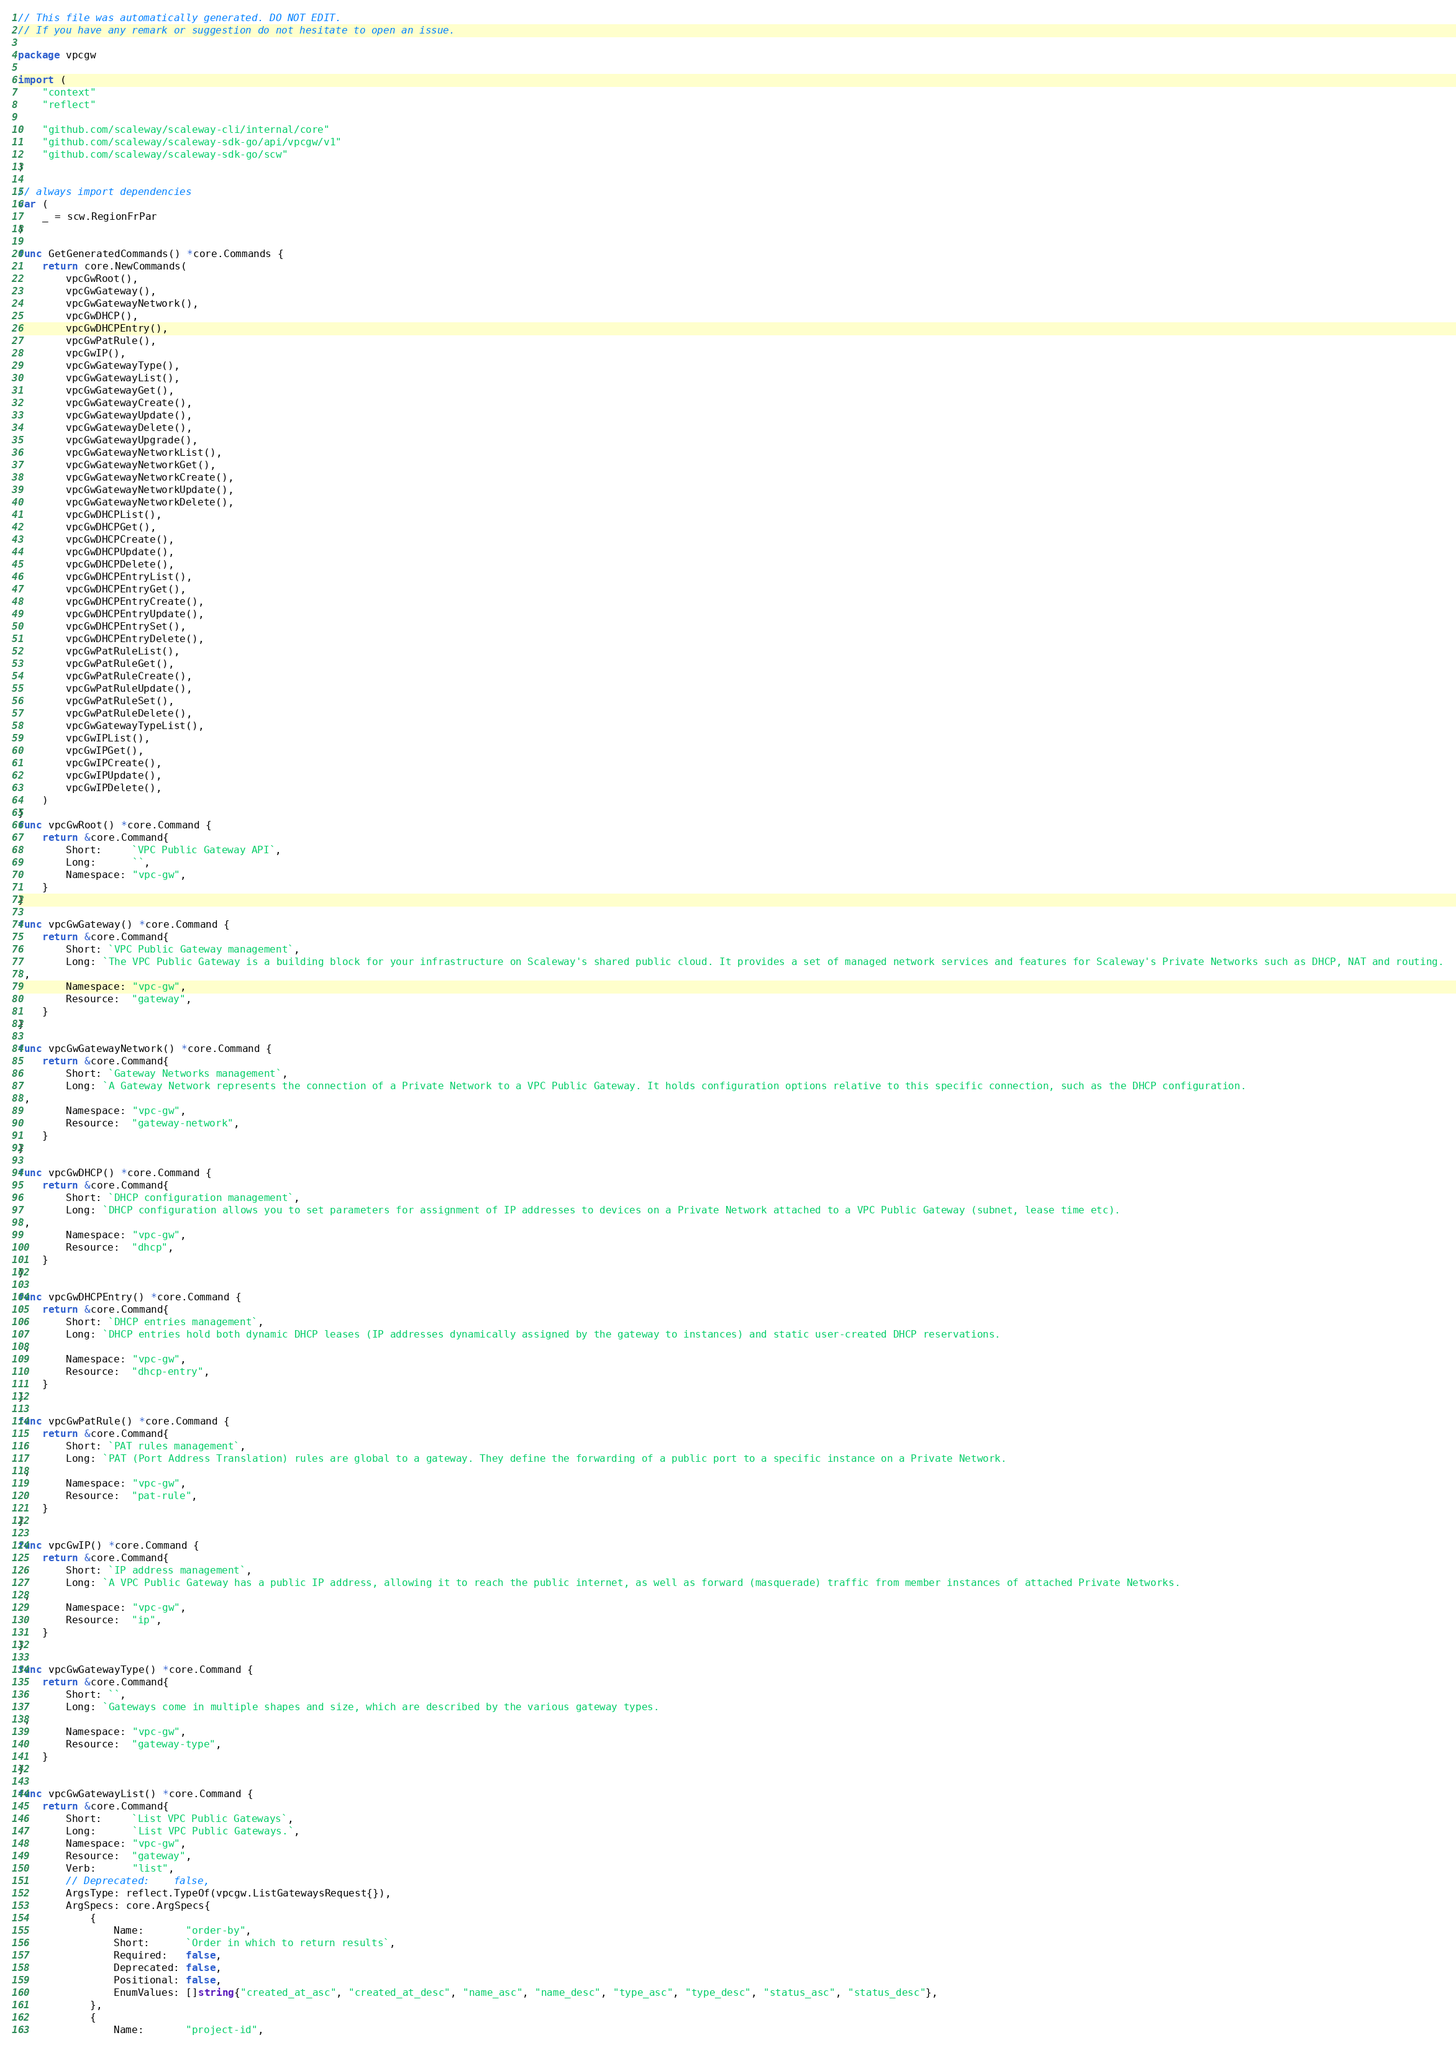Convert code to text. <code><loc_0><loc_0><loc_500><loc_500><_Go_>// This file was automatically generated. DO NOT EDIT.
// If you have any remark or suggestion do not hesitate to open an issue.

package vpcgw

import (
	"context"
	"reflect"

	"github.com/scaleway/scaleway-cli/internal/core"
	"github.com/scaleway/scaleway-sdk-go/api/vpcgw/v1"
	"github.com/scaleway/scaleway-sdk-go/scw"
)

// always import dependencies
var (
	_ = scw.RegionFrPar
)

func GetGeneratedCommands() *core.Commands {
	return core.NewCommands(
		vpcGwRoot(),
		vpcGwGateway(),
		vpcGwGatewayNetwork(),
		vpcGwDHCP(),
		vpcGwDHCPEntry(),
		vpcGwPatRule(),
		vpcGwIP(),
		vpcGwGatewayType(),
		vpcGwGatewayList(),
		vpcGwGatewayGet(),
		vpcGwGatewayCreate(),
		vpcGwGatewayUpdate(),
		vpcGwGatewayDelete(),
		vpcGwGatewayUpgrade(),
		vpcGwGatewayNetworkList(),
		vpcGwGatewayNetworkGet(),
		vpcGwGatewayNetworkCreate(),
		vpcGwGatewayNetworkUpdate(),
		vpcGwGatewayNetworkDelete(),
		vpcGwDHCPList(),
		vpcGwDHCPGet(),
		vpcGwDHCPCreate(),
		vpcGwDHCPUpdate(),
		vpcGwDHCPDelete(),
		vpcGwDHCPEntryList(),
		vpcGwDHCPEntryGet(),
		vpcGwDHCPEntryCreate(),
		vpcGwDHCPEntryUpdate(),
		vpcGwDHCPEntrySet(),
		vpcGwDHCPEntryDelete(),
		vpcGwPatRuleList(),
		vpcGwPatRuleGet(),
		vpcGwPatRuleCreate(),
		vpcGwPatRuleUpdate(),
		vpcGwPatRuleSet(),
		vpcGwPatRuleDelete(),
		vpcGwGatewayTypeList(),
		vpcGwIPList(),
		vpcGwIPGet(),
		vpcGwIPCreate(),
		vpcGwIPUpdate(),
		vpcGwIPDelete(),
	)
}
func vpcGwRoot() *core.Command {
	return &core.Command{
		Short:     `VPC Public Gateway API`,
		Long:      ``,
		Namespace: "vpc-gw",
	}
}

func vpcGwGateway() *core.Command {
	return &core.Command{
		Short: `VPC Public Gateway management`,
		Long: `The VPC Public Gateway is a building block for your infrastructure on Scaleway's shared public cloud. It provides a set of managed network services and features for Scaleway's Private Networks such as DHCP, NAT and routing.
`,
		Namespace: "vpc-gw",
		Resource:  "gateway",
	}
}

func vpcGwGatewayNetwork() *core.Command {
	return &core.Command{
		Short: `Gateway Networks management`,
		Long: `A Gateway Network represents the connection of a Private Network to a VPC Public Gateway. It holds configuration options relative to this specific connection, such as the DHCP configuration.
`,
		Namespace: "vpc-gw",
		Resource:  "gateway-network",
	}
}

func vpcGwDHCP() *core.Command {
	return &core.Command{
		Short: `DHCP configuration management`,
		Long: `DHCP configuration allows you to set parameters for assignment of IP addresses to devices on a Private Network attached to a VPC Public Gateway (subnet, lease time etc).
`,
		Namespace: "vpc-gw",
		Resource:  "dhcp",
	}
}

func vpcGwDHCPEntry() *core.Command {
	return &core.Command{
		Short: `DHCP entries management`,
		Long: `DHCP entries hold both dynamic DHCP leases (IP addresses dynamically assigned by the gateway to instances) and static user-created DHCP reservations.
`,
		Namespace: "vpc-gw",
		Resource:  "dhcp-entry",
	}
}

func vpcGwPatRule() *core.Command {
	return &core.Command{
		Short: `PAT rules management`,
		Long: `PAT (Port Address Translation) rules are global to a gateway. They define the forwarding of a public port to a specific instance on a Private Network.
`,
		Namespace: "vpc-gw",
		Resource:  "pat-rule",
	}
}

func vpcGwIP() *core.Command {
	return &core.Command{
		Short: `IP address management`,
		Long: `A VPC Public Gateway has a public IP address, allowing it to reach the public internet, as well as forward (masquerade) traffic from member instances of attached Private Networks.
`,
		Namespace: "vpc-gw",
		Resource:  "ip",
	}
}

func vpcGwGatewayType() *core.Command {
	return &core.Command{
		Short: ``,
		Long: `Gateways come in multiple shapes and size, which are described by the various gateway types.
`,
		Namespace: "vpc-gw",
		Resource:  "gateway-type",
	}
}

func vpcGwGatewayList() *core.Command {
	return &core.Command{
		Short:     `List VPC Public Gateways`,
		Long:      `List VPC Public Gateways.`,
		Namespace: "vpc-gw",
		Resource:  "gateway",
		Verb:      "list",
		// Deprecated:    false,
		ArgsType: reflect.TypeOf(vpcgw.ListGatewaysRequest{}),
		ArgSpecs: core.ArgSpecs{
			{
				Name:       "order-by",
				Short:      `Order in which to return results`,
				Required:   false,
				Deprecated: false,
				Positional: false,
				EnumValues: []string{"created_at_asc", "created_at_desc", "name_asc", "name_desc", "type_asc", "type_desc", "status_asc", "status_desc"},
			},
			{
				Name:       "project-id",</code> 